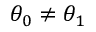Convert formula to latex. <formula><loc_0><loc_0><loc_500><loc_500>\theta _ { 0 } \neq \theta _ { 1 }</formula> 